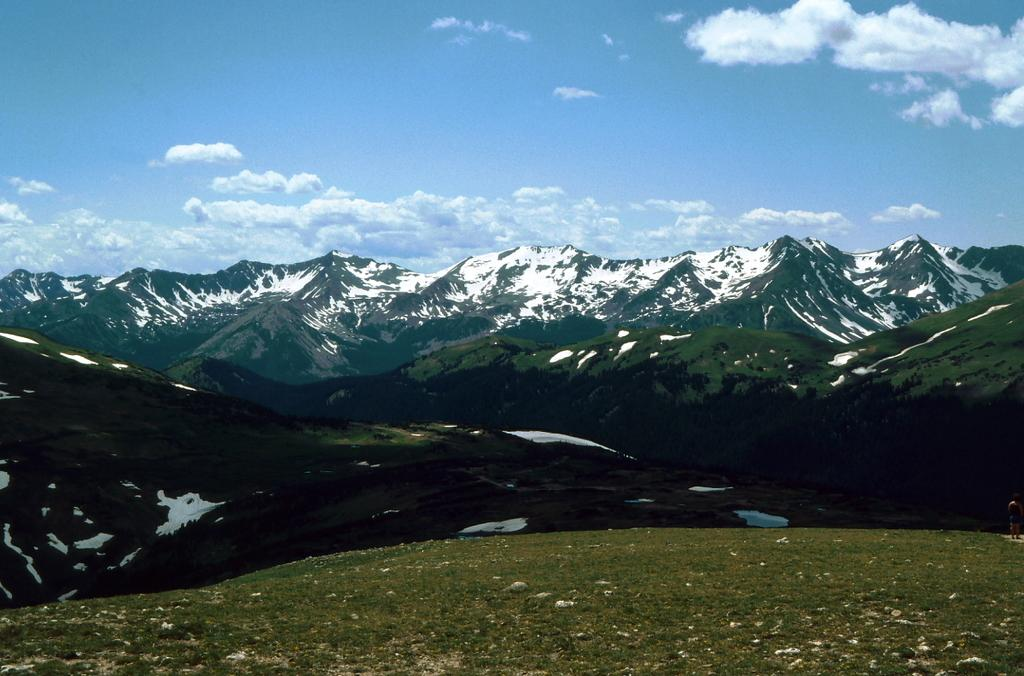What type of vegetation is present in the image? There is grass in the image. What geographical features can be seen in the image? There are mountains in the image. What type of weather condition is depicted in the image? There is snow in the image, suggesting a cold or wintry condition. What else is visible in the sky in the image? There are clouds in the image. What is visible in the background of the image? The sky is visible in the background of the image. What type of silk is being used to make the son's outfit in the image? There is no son or silk present in the image; it features grass, mountains, snow, clouds, and the sky. 